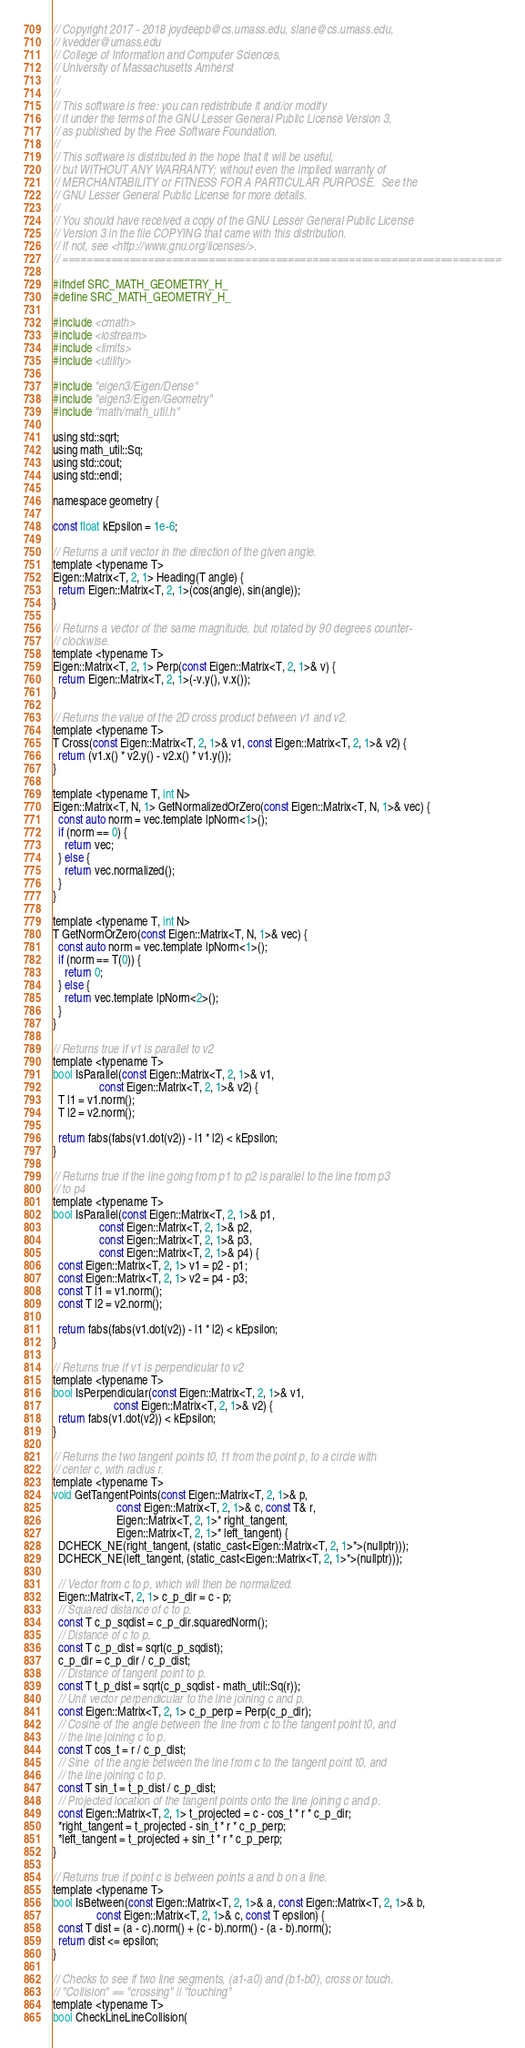Convert code to text. <code><loc_0><loc_0><loc_500><loc_500><_C_>// Copyright 2017 - 2018 joydeepb@cs.umass.edu, slane@cs.umass.edu,
// kvedder@umass.edu
// College of Information and Computer Sciences,
// University of Massachusetts Amherst
//
//
// This software is free: you can redistribute it and/or modify
// it under the terms of the GNU Lesser General Public License Version 3,
// as published by the Free Software Foundation.
//
// This software is distributed in the hope that it will be useful,
// but WITHOUT ANY WARRANTY; without even the implied warranty of
// MERCHANTABILITY or FITNESS FOR A PARTICULAR PURPOSE.  See the
// GNU Lesser General Public License for more details.
//
// You should have received a copy of the GNU Lesser General Public License
// Version 3 in the file COPYING that came with this distribution.
// If not, see <http://www.gnu.org/licenses/>.
// ========================================================================

#ifndef SRC_MATH_GEOMETRY_H_
#define SRC_MATH_GEOMETRY_H_

#include <cmath>
#include <iostream>
#include <limits>
#include <utility>

#include "eigen3/Eigen/Dense"
#include "eigen3/Eigen/Geometry"
#include "math/math_util.h"

using std::sqrt;
using math_util::Sq;
using std::cout;
using std::endl;

namespace geometry {

const float kEpsilon = 1e-6;

// Returns a unit vector in the direction of the given angle.
template <typename T>
Eigen::Matrix<T, 2, 1> Heading(T angle) {
  return Eigen::Matrix<T, 2, 1>(cos(angle), sin(angle));
}

// Returns a vector of the same magnitude, but rotated by 90 degrees counter-
// clockwise.
template <typename T>
Eigen::Matrix<T, 2, 1> Perp(const Eigen::Matrix<T, 2, 1>& v) {
  return Eigen::Matrix<T, 2, 1>(-v.y(), v.x());
}

// Returns the value of the 2D cross product between v1 and v2.
template <typename T>
T Cross(const Eigen::Matrix<T, 2, 1>& v1, const Eigen::Matrix<T, 2, 1>& v2) {
  return (v1.x() * v2.y() - v2.x() * v1.y());
}

template <typename T, int N>
Eigen::Matrix<T, N, 1> GetNormalizedOrZero(const Eigen::Matrix<T, N, 1>& vec) {
  const auto norm = vec.template lpNorm<1>();
  if (norm == 0) {
    return vec;
  } else {
    return vec.normalized();
  }
}

template <typename T, int N>
T GetNormOrZero(const Eigen::Matrix<T, N, 1>& vec) {
  const auto norm = vec.template lpNorm<1>();
  if (norm == T(0)) {
    return 0;
  } else {
    return vec.template lpNorm<2>();
  }
}

// Returns true if v1 is parallel to v2
template <typename T>
bool IsParallel(const Eigen::Matrix<T, 2, 1>& v1,
                const Eigen::Matrix<T, 2, 1>& v2) {
  T l1 = v1.norm();
  T l2 = v2.norm();

  return fabs(fabs(v1.dot(v2)) - l1 * l2) < kEpsilon;
}

// Returns true if the line going from p1 to p2 is parallel to the line from p3
// to p4
template <typename T>
bool IsParallel(const Eigen::Matrix<T, 2, 1>& p1,
                const Eigen::Matrix<T, 2, 1>& p2,
                const Eigen::Matrix<T, 2, 1>& p3,
                const Eigen::Matrix<T, 2, 1>& p4) {
  const Eigen::Matrix<T, 2, 1> v1 = p2 - p1;
  const Eigen::Matrix<T, 2, 1> v2 = p4 - p3;
  const T l1 = v1.norm();
  const T l2 = v2.norm();

  return fabs(fabs(v1.dot(v2)) - l1 * l2) < kEpsilon;
}

// Returns true if v1 is perpendicular to v2
template <typename T>
bool IsPerpendicular(const Eigen::Matrix<T, 2, 1>& v1,
                     const Eigen::Matrix<T, 2, 1>& v2) {
  return fabs(v1.dot(v2)) < kEpsilon;
}

// Returns the two tangent points t0, t1 from the point p, to a circle with
// center c, with radius r.
template <typename T>
void GetTangentPoints(const Eigen::Matrix<T, 2, 1>& p,
                      const Eigen::Matrix<T, 2, 1>& c, const T& r,
                      Eigen::Matrix<T, 2, 1>* right_tangent,
                      Eigen::Matrix<T, 2, 1>* left_tangent) {
  DCHECK_NE(right_tangent, (static_cast<Eigen::Matrix<T, 2, 1>*>(nullptr)));
  DCHECK_NE(left_tangent, (static_cast<Eigen::Matrix<T, 2, 1>*>(nullptr)));

  // Vector from c to p, which will then be normalized.
  Eigen::Matrix<T, 2, 1> c_p_dir = c - p;
  // Squared distance of c to p.
  const T c_p_sqdist = c_p_dir.squaredNorm();
  // Distance of c to p.
  const T c_p_dist = sqrt(c_p_sqdist);
  c_p_dir = c_p_dir / c_p_dist;
  // Distance of tangent point to p.
  const T t_p_dist = sqrt(c_p_sqdist - math_util::Sq(r));
  // Unit vector perpendicular to the line joining c and p.
  const Eigen::Matrix<T, 2, 1> c_p_perp = Perp(c_p_dir);
  // Cosine of the angle between the line from c to the tangent point t0, and
  // the line joining c to p.
  const T cos_t = r / c_p_dist;
  // Sine  of the angle between the line from c to the tangent point t0, and
  // the line joining c to p.
  const T sin_t = t_p_dist / c_p_dist;
  // Projected location of the tangent points onto the line joining c and p.
  const Eigen::Matrix<T, 2, 1> t_projected = c - cos_t * r * c_p_dir;
  *right_tangent = t_projected - sin_t * r * c_p_perp;
  *left_tangent = t_projected + sin_t * r * c_p_perp;
}

// Returns true if point c is between points a and b on a line.
template <typename T>
bool IsBetween(const Eigen::Matrix<T, 2, 1>& a, const Eigen::Matrix<T, 2, 1>& b,
               const Eigen::Matrix<T, 2, 1>& c, const T epsilon) {
  const T dist = (a - c).norm() + (c - b).norm() - (a - b).norm();
  return dist <= epsilon;
}

// Checks to see if two line segments, (a1-a0) and (b1-b0), cross or touch.
// "Collision" == "crossing" || "touching"
template <typename T>
bool CheckLineLineCollision(</code> 